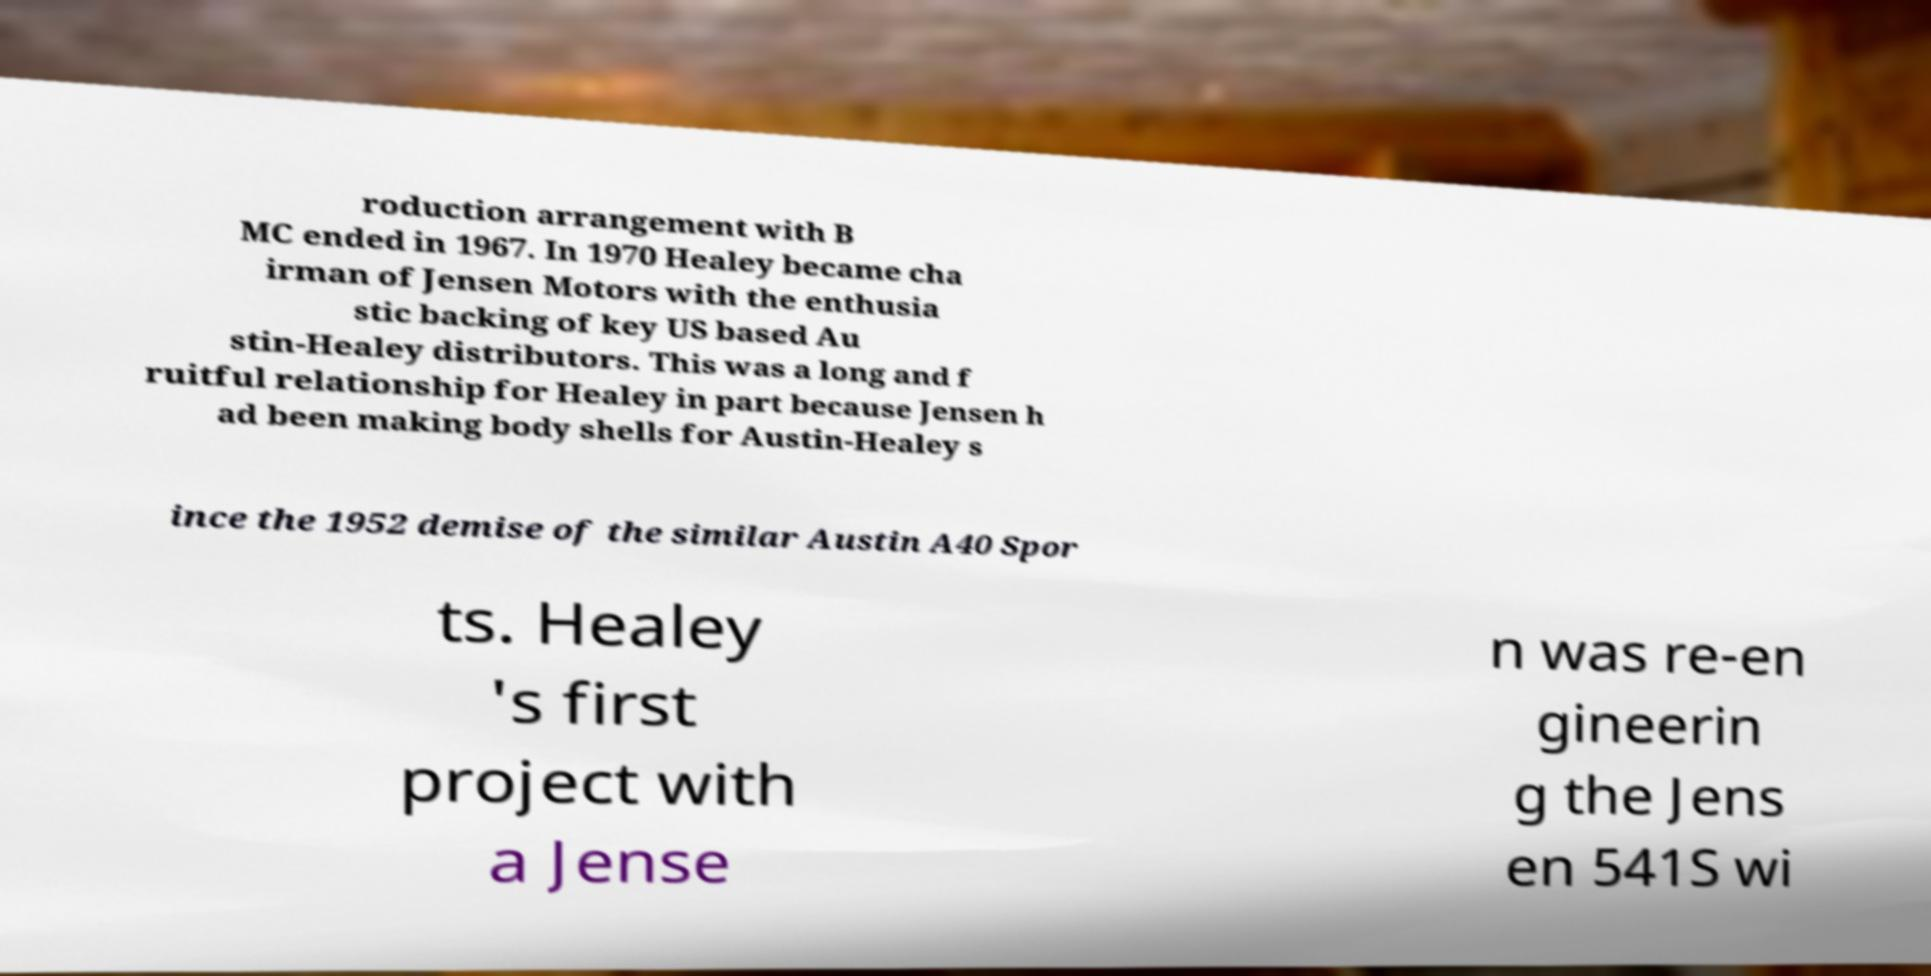Can you read and provide the text displayed in the image?This photo seems to have some interesting text. Can you extract and type it out for me? roduction arrangement with B MC ended in 1967. In 1970 Healey became cha irman of Jensen Motors with the enthusia stic backing of key US based Au stin-Healey distributors. This was a long and f ruitful relationship for Healey in part because Jensen h ad been making body shells for Austin-Healey s ince the 1952 demise of the similar Austin A40 Spor ts. Healey 's first project with a Jense n was re-en gineerin g the Jens en 541S wi 